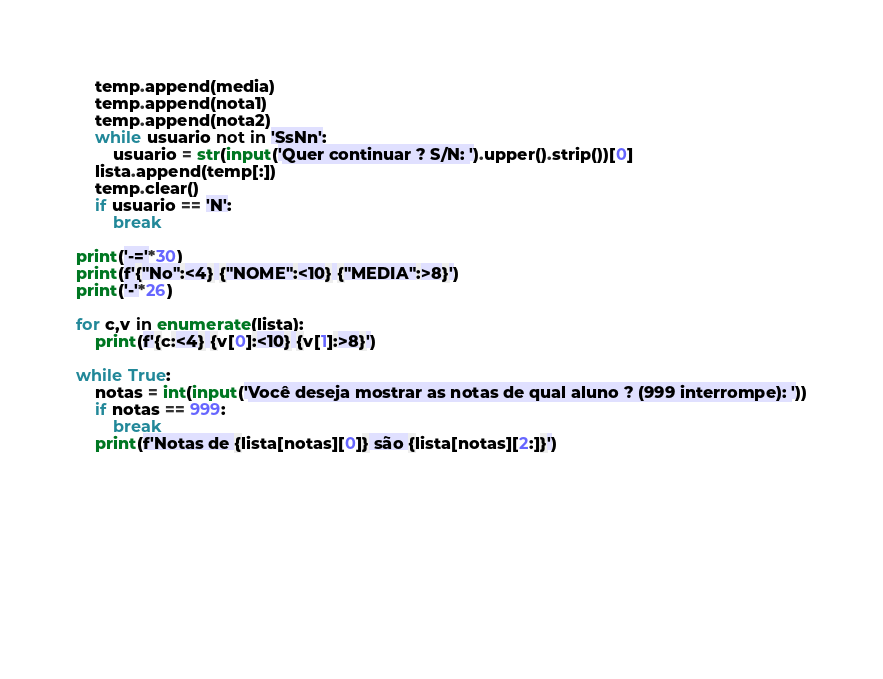<code> <loc_0><loc_0><loc_500><loc_500><_Python_>    temp.append(media)
    temp.append(nota1)
    temp.append(nota2)
    while usuario not in 'SsNn':
        usuario = str(input('Quer continuar ? S/N: ').upper().strip())[0]
    lista.append(temp[:])
    temp.clear()
    if usuario == 'N':
        break

print('-='*30)
print(f'{"No":<4} {"NOME":<10} {"MEDIA":>8}')
print('-'*26)

for c,v in enumerate(lista):
    print(f'{c:<4} {v[0]:<10} {v[1]:>8}')

while True:
    notas = int(input('Você deseja mostrar as notas de qual aluno ? (999 interrompe): '))
    if notas == 999:
        break
    print(f'Notas de {lista[notas][0]} são {lista[notas][2:]}')

    
    


   
    

    </code> 